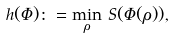Convert formula to latex. <formula><loc_0><loc_0><loc_500><loc_500>h ( \Phi ) \colon = \min _ { \rho } \, S ( \Phi ( \rho ) ) ,</formula> 